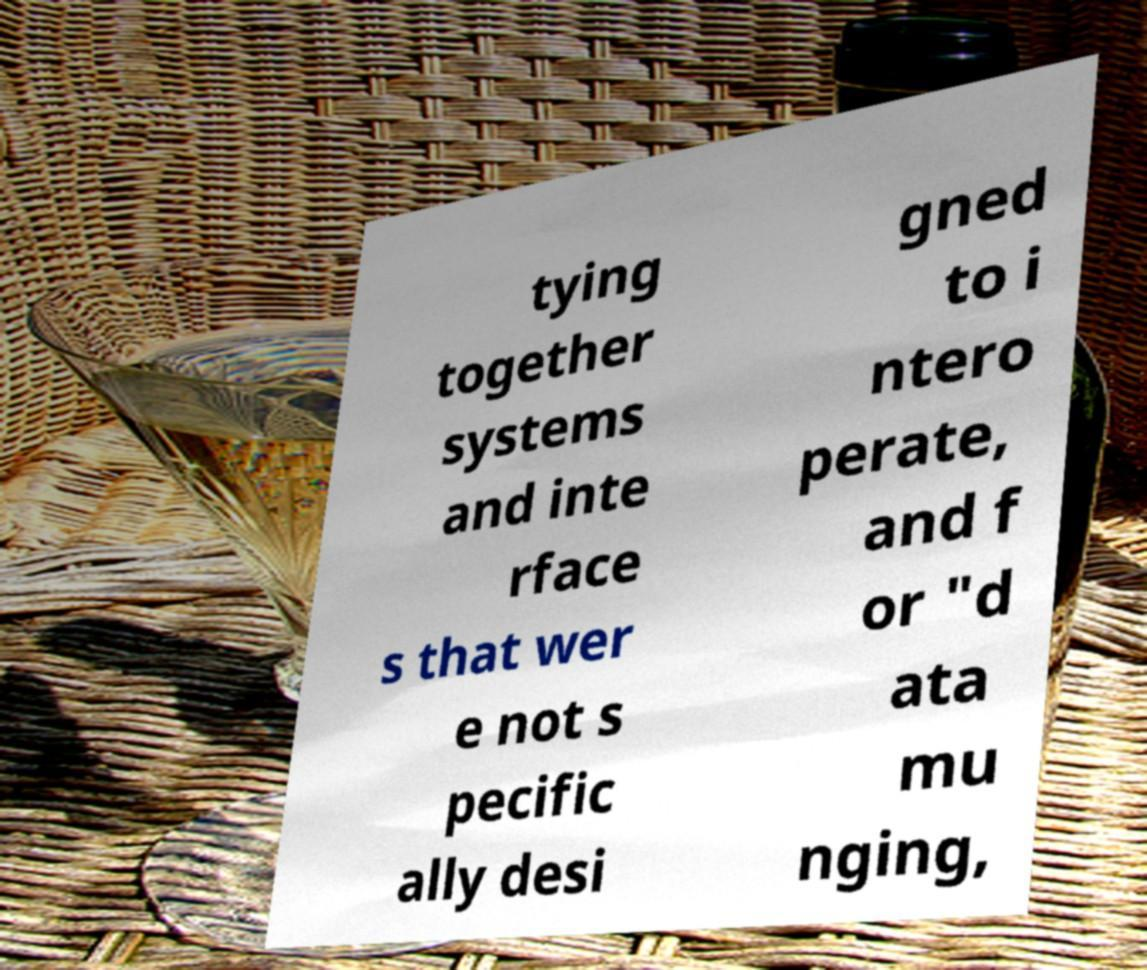Please read and relay the text visible in this image. What does it say? tying together systems and inte rface s that wer e not s pecific ally desi gned to i ntero perate, and f or "d ata mu nging, 